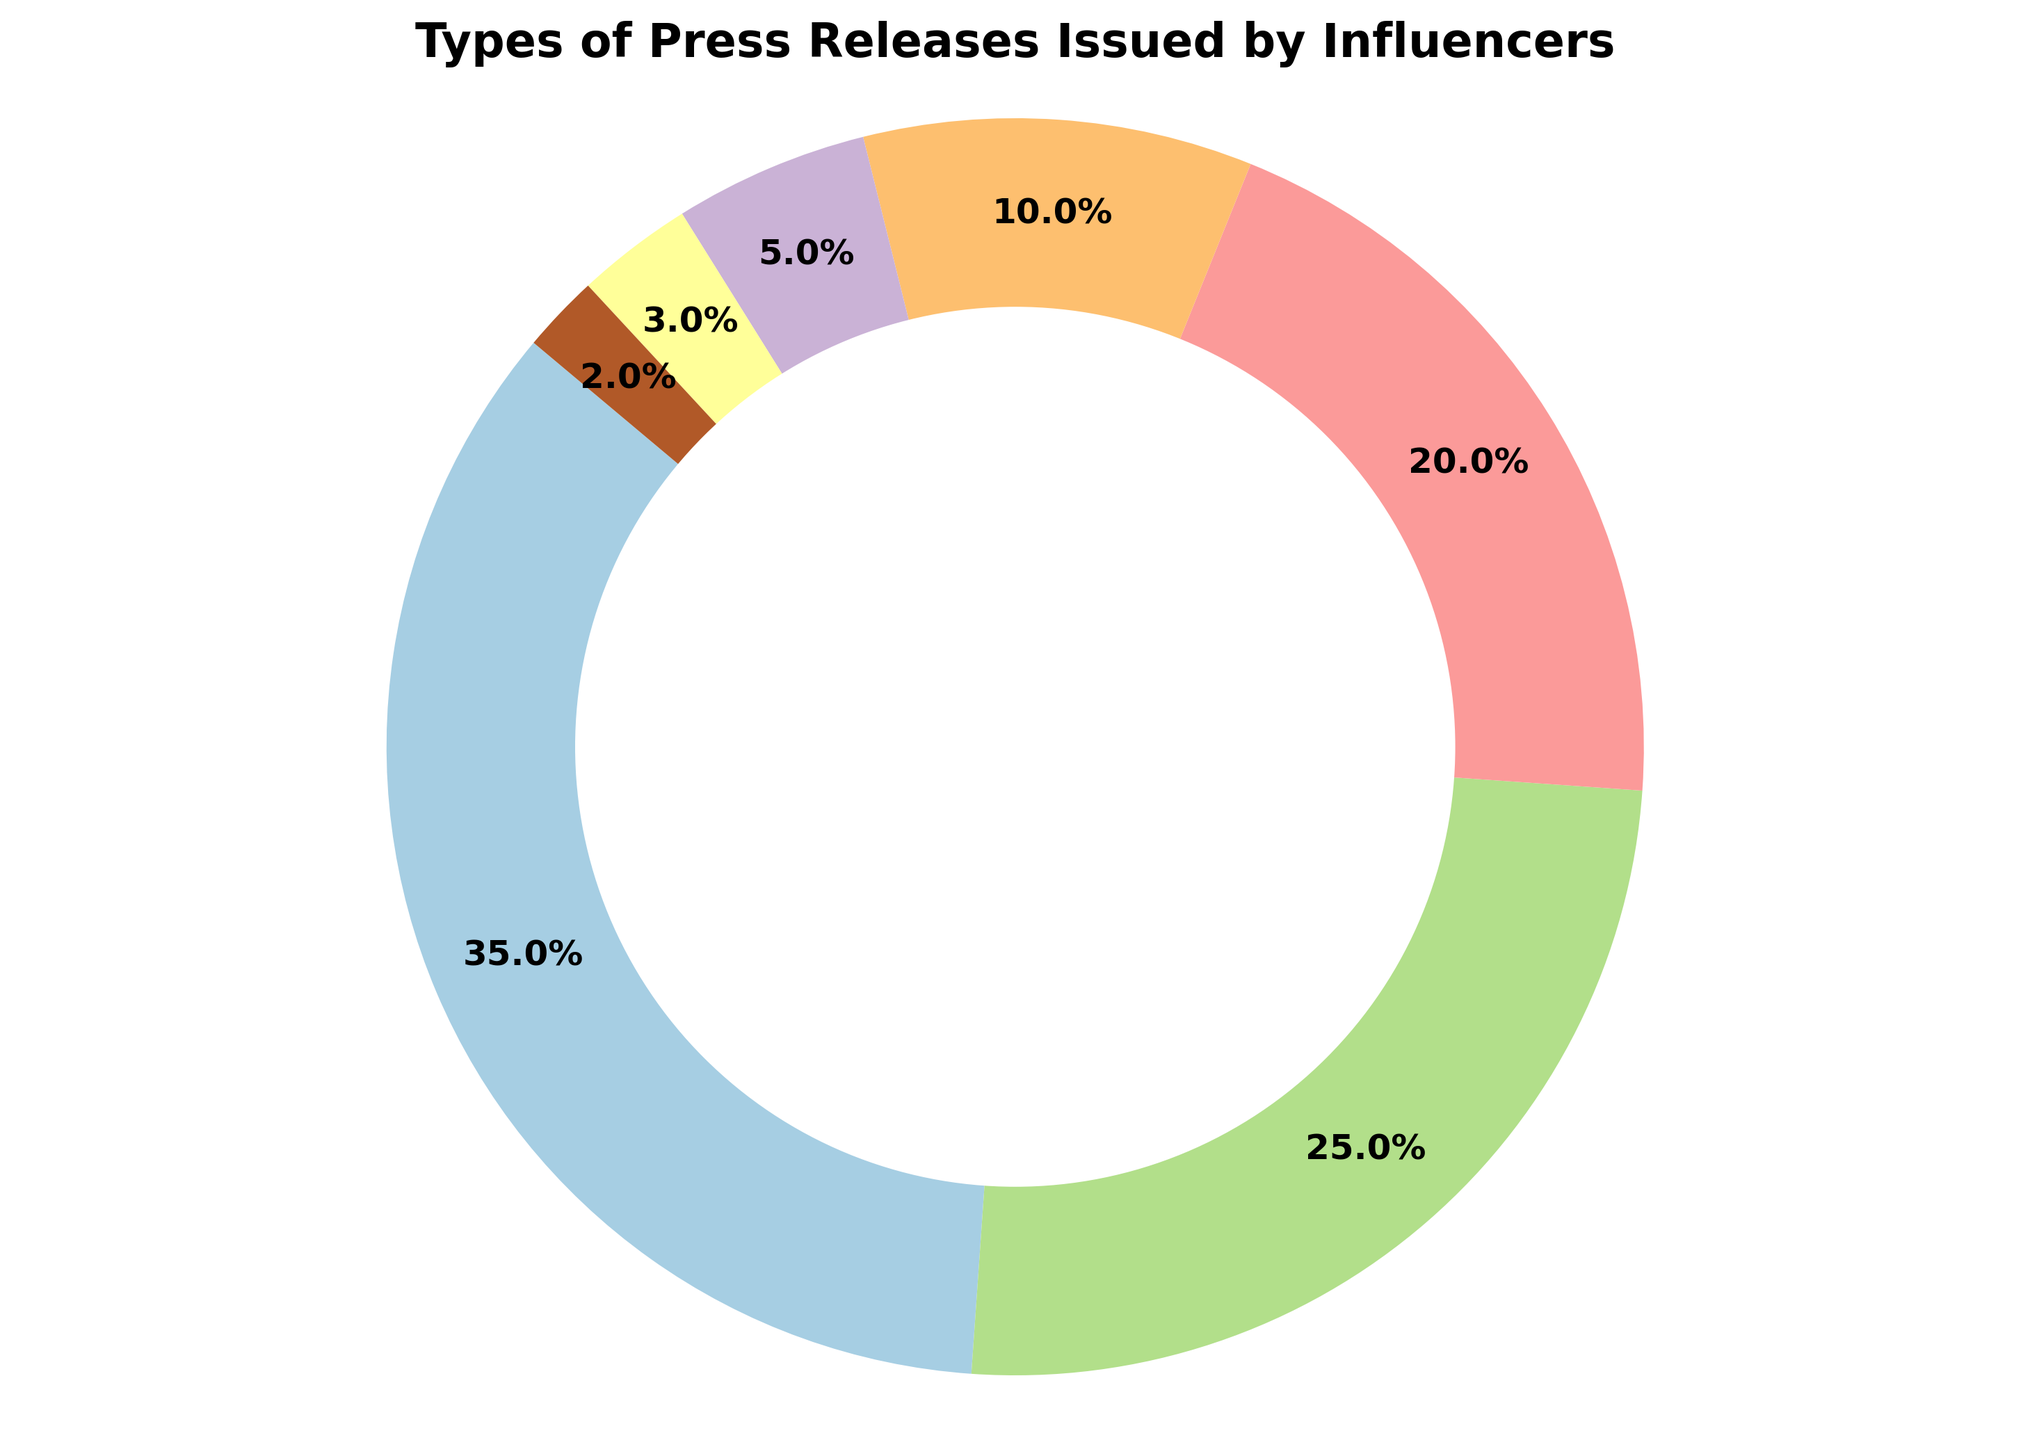Which category has the largest percentage of press releases issued by influencers? By looking at the pie chart, the largest segment represents the category labeled 'Product Launches,' which has a percentage of 35%.
Answer: Product Launches Which category has the smallest percentage of press releases issued by influencers? The smallest segment in the pie chart represents the category labeled 'Other,' which has a percentage of 2%.
Answer: Other What is the combined percentage of 'Brand Partnerships' and 'Event Announcements'? To find the combined percentage, add the individual percentages of 'Brand Partnerships' and 'Event Announcements': 25% + 20% = 45%.
Answer: 45% How much greater is the percentage of 'Product Launches' compared to 'Milestones/Achievements'? Subtract the percentage of 'Milestones/Achievements' from 'Product Launches': 35% - 10% = 25%.
Answer: 25% Which category has a larger percentage of press releases, 'Philanthropy/Charity Work' or 'Personal Updates'? By comparing the segments of the pie chart, 'Philanthropy/Charity Work' has a larger percentage (5%) than 'Personal Updates' (3%).
Answer: Philanthropy/Charity Work What is the total percentage covered by 'Product Launches,' 'Brand Partnerships,' and 'Event Announcements'? To find the total percentage covered by these three categories, add their individual percentages: 35% + 25% + 20% = 80%.
Answer: 80% Is the percentage of 'Personal Updates' greater or less than the percentage of 'Philanthropy/Charity Work'? By comparing the segments of the pie chart, 'Personal Updates' (3%) is less than 'Philanthropy/Charity Work' (5%).
Answer: Less Which segment is visually the smallest in the pie chart? By looking at the pie chart, the visually smallest segment corresponds to the category labeled 'Other,' with a percentage of 2%.
Answer: Other What is the difference in percentage between 'Brand Partnerships' and 'Event Announcements'? Subtract the percentage of 'Event Announcements' from 'Brand Partnerships': 25% - 20% = 5%.
Answer: 5% How does the percentage of 'Milestones/Achievements' compare to that of 'Philanthropy/Charity Work' and 'Personal Updates' combined? Add the percentages of 'Philanthropy/Charity Work' and 'Personal Updates': 5% + 3% = 8%. Then, compare this to 'Milestones/Achievements' which is 10%. The difference is 10% - 8% = 2%, so 'Milestones/Achievements' is 2% greater.
Answer: 2% greater 